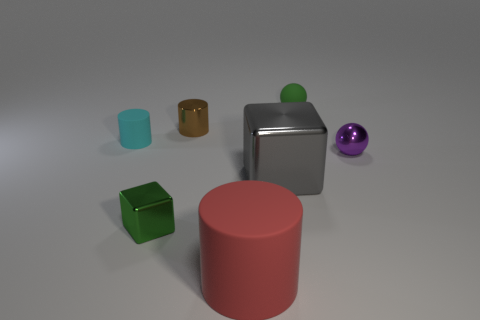What time of day does this lighting suggest? The lighting in the image is soft and diffused with subtle shadows, suggesting an indoor environment, possibly illuminated by artificial lighting rather than a specific time of day. 